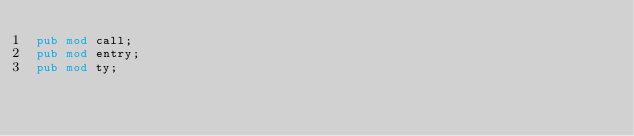<code> <loc_0><loc_0><loc_500><loc_500><_Rust_>pub mod call;
pub mod entry;
pub mod ty;
</code> 